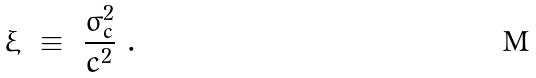Convert formula to latex. <formula><loc_0><loc_0><loc_500><loc_500>\xi \ \equiv \ \frac { \sigma _ { c } ^ { 2 } } { c ^ { 2 } } \ .</formula> 